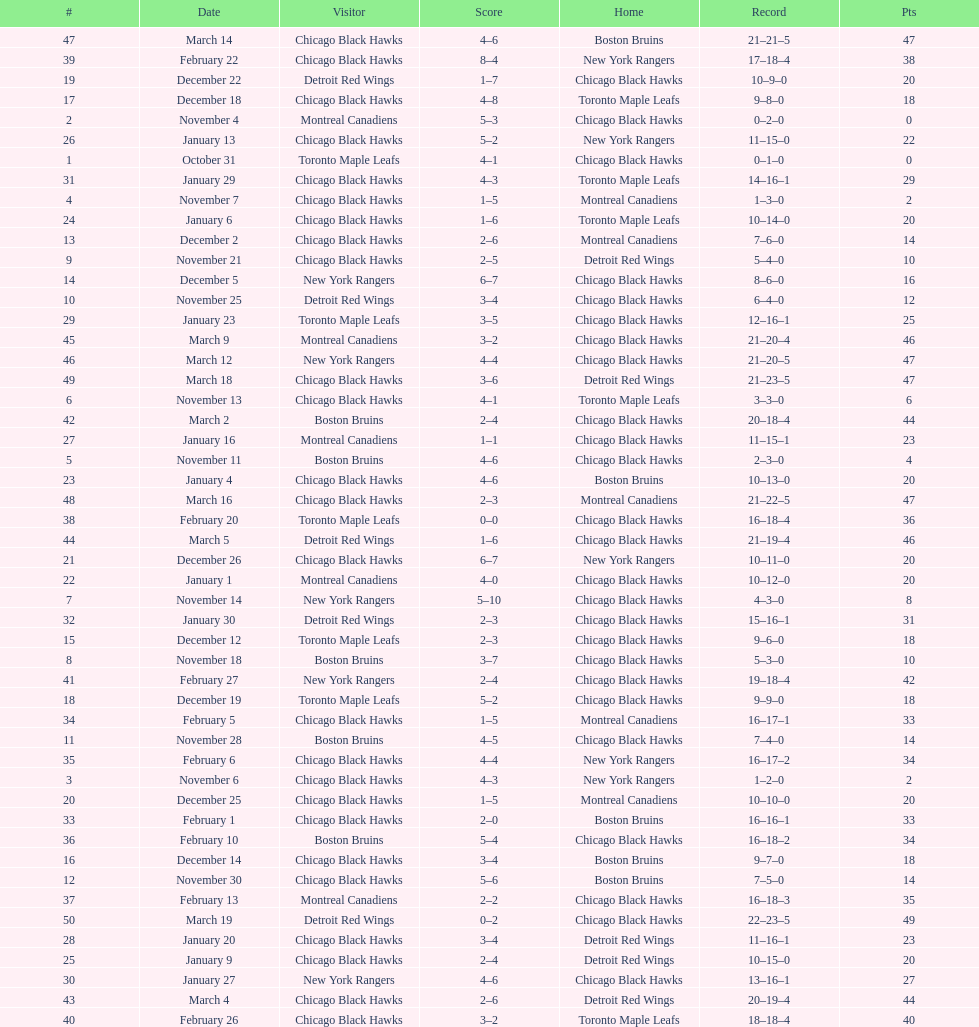What was the total amount of points scored on november 4th? 8. Could you parse the entire table as a dict? {'header': ['#', 'Date', 'Visitor', 'Score', 'Home', 'Record', 'Pts'], 'rows': [['47', 'March 14', 'Chicago Black Hawks', '4–6', 'Boston Bruins', '21–21–5', '47'], ['39', 'February 22', 'Chicago Black Hawks', '8–4', 'New York Rangers', '17–18–4', '38'], ['19', 'December 22', 'Detroit Red Wings', '1–7', 'Chicago Black Hawks', '10–9–0', '20'], ['17', 'December 18', 'Chicago Black Hawks', '4–8', 'Toronto Maple Leafs', '9–8–0', '18'], ['2', 'November 4', 'Montreal Canadiens', '5–3', 'Chicago Black Hawks', '0–2–0', '0'], ['26', 'January 13', 'Chicago Black Hawks', '5–2', 'New York Rangers', '11–15–0', '22'], ['1', 'October 31', 'Toronto Maple Leafs', '4–1', 'Chicago Black Hawks', '0–1–0', '0'], ['31', 'January 29', 'Chicago Black Hawks', '4–3', 'Toronto Maple Leafs', '14–16–1', '29'], ['4', 'November 7', 'Chicago Black Hawks', '1–5', 'Montreal Canadiens', '1–3–0', '2'], ['24', 'January 6', 'Chicago Black Hawks', '1–6', 'Toronto Maple Leafs', '10–14–0', '20'], ['13', 'December 2', 'Chicago Black Hawks', '2–6', 'Montreal Canadiens', '7–6–0', '14'], ['9', 'November 21', 'Chicago Black Hawks', '2–5', 'Detroit Red Wings', '5–4–0', '10'], ['14', 'December 5', 'New York Rangers', '6–7', 'Chicago Black Hawks', '8–6–0', '16'], ['10', 'November 25', 'Detroit Red Wings', '3–4', 'Chicago Black Hawks', '6–4–0', '12'], ['29', 'January 23', 'Toronto Maple Leafs', '3–5', 'Chicago Black Hawks', '12–16–1', '25'], ['45', 'March 9', 'Montreal Canadiens', '3–2', 'Chicago Black Hawks', '21–20–4', '46'], ['46', 'March 12', 'New York Rangers', '4–4', 'Chicago Black Hawks', '21–20–5', '47'], ['49', 'March 18', 'Chicago Black Hawks', '3–6', 'Detroit Red Wings', '21–23–5', '47'], ['6', 'November 13', 'Chicago Black Hawks', '4–1', 'Toronto Maple Leafs', '3–3–0', '6'], ['42', 'March 2', 'Boston Bruins', '2–4', 'Chicago Black Hawks', '20–18–4', '44'], ['27', 'January 16', 'Montreal Canadiens', '1–1', 'Chicago Black Hawks', '11–15–1', '23'], ['5', 'November 11', 'Boston Bruins', '4–6', 'Chicago Black Hawks', '2–3–0', '4'], ['23', 'January 4', 'Chicago Black Hawks', '4–6', 'Boston Bruins', '10–13–0', '20'], ['48', 'March 16', 'Chicago Black Hawks', '2–3', 'Montreal Canadiens', '21–22–5', '47'], ['38', 'February 20', 'Toronto Maple Leafs', '0–0', 'Chicago Black Hawks', '16–18–4', '36'], ['44', 'March 5', 'Detroit Red Wings', '1–6', 'Chicago Black Hawks', '21–19–4', '46'], ['21', 'December 26', 'Chicago Black Hawks', '6–7', 'New York Rangers', '10–11–0', '20'], ['22', 'January 1', 'Montreal Canadiens', '4–0', 'Chicago Black Hawks', '10–12–0', '20'], ['7', 'November 14', 'New York Rangers', '5–10', 'Chicago Black Hawks', '4–3–0', '8'], ['32', 'January 30', 'Detroit Red Wings', '2–3', 'Chicago Black Hawks', '15–16–1', '31'], ['15', 'December 12', 'Toronto Maple Leafs', '2–3', 'Chicago Black Hawks', '9–6–0', '18'], ['8', 'November 18', 'Boston Bruins', '3–7', 'Chicago Black Hawks', '5–3–0', '10'], ['41', 'February 27', 'New York Rangers', '2–4', 'Chicago Black Hawks', '19–18–4', '42'], ['18', 'December 19', 'Toronto Maple Leafs', '5–2', 'Chicago Black Hawks', '9–9–0', '18'], ['34', 'February 5', 'Chicago Black Hawks', '1–5', 'Montreal Canadiens', '16–17–1', '33'], ['11', 'November 28', 'Boston Bruins', '4–5', 'Chicago Black Hawks', '7–4–0', '14'], ['35', 'February 6', 'Chicago Black Hawks', '4–4', 'New York Rangers', '16–17–2', '34'], ['3', 'November 6', 'Chicago Black Hawks', '4–3', 'New York Rangers', '1–2–0', '2'], ['20', 'December 25', 'Chicago Black Hawks', '1–5', 'Montreal Canadiens', '10–10–0', '20'], ['33', 'February 1', 'Chicago Black Hawks', '2–0', 'Boston Bruins', '16–16–1', '33'], ['36', 'February 10', 'Boston Bruins', '5–4', 'Chicago Black Hawks', '16–18–2', '34'], ['16', 'December 14', 'Chicago Black Hawks', '3–4', 'Boston Bruins', '9–7–0', '18'], ['12', 'November 30', 'Chicago Black Hawks', '5–6', 'Boston Bruins', '7–5–0', '14'], ['37', 'February 13', 'Montreal Canadiens', '2–2', 'Chicago Black Hawks', '16–18–3', '35'], ['50', 'March 19', 'Detroit Red Wings', '0–2', 'Chicago Black Hawks', '22–23–5', '49'], ['28', 'January 20', 'Chicago Black Hawks', '3–4', 'Detroit Red Wings', '11–16–1', '23'], ['25', 'January 9', 'Chicago Black Hawks', '2–4', 'Detroit Red Wings', '10–15–0', '20'], ['30', 'January 27', 'New York Rangers', '4–6', 'Chicago Black Hawks', '13–16–1', '27'], ['43', 'March 4', 'Chicago Black Hawks', '2–6', 'Detroit Red Wings', '20–19–4', '44'], ['40', 'February 26', 'Chicago Black Hawks', '3–2', 'Toronto Maple Leafs', '18–18–4', '40']]} 